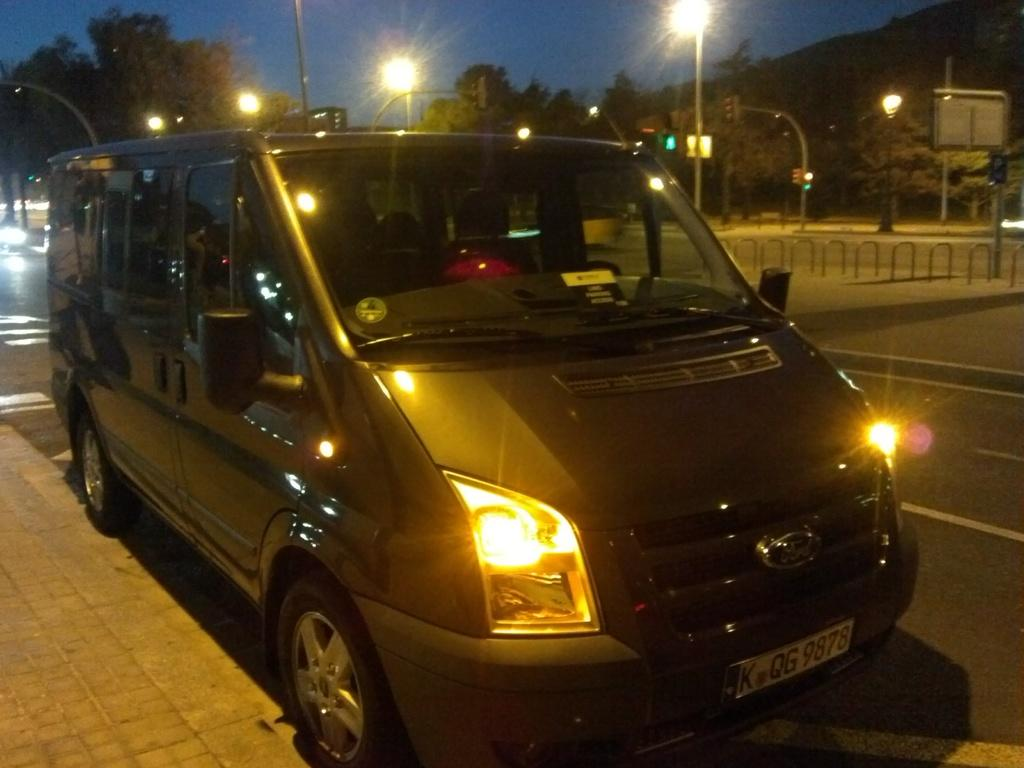What is on the road in the image? There is a vehicle on the road in the image. What can be seen in the background of the image? In the background of the image, there are lights, boards, a traffic signal, poles, trees, rods, and the sky. Can you describe the traffic signal in the image? The traffic signal is in the background of the image. What type of objects are present in the background of the image? The objects in the background of the image include lights, boards, a traffic signal, poles, trees, rods, and the sky. What type of cable is being used to celebrate the birthday in the image? There is no mention of a birthday or any cables in the image. 